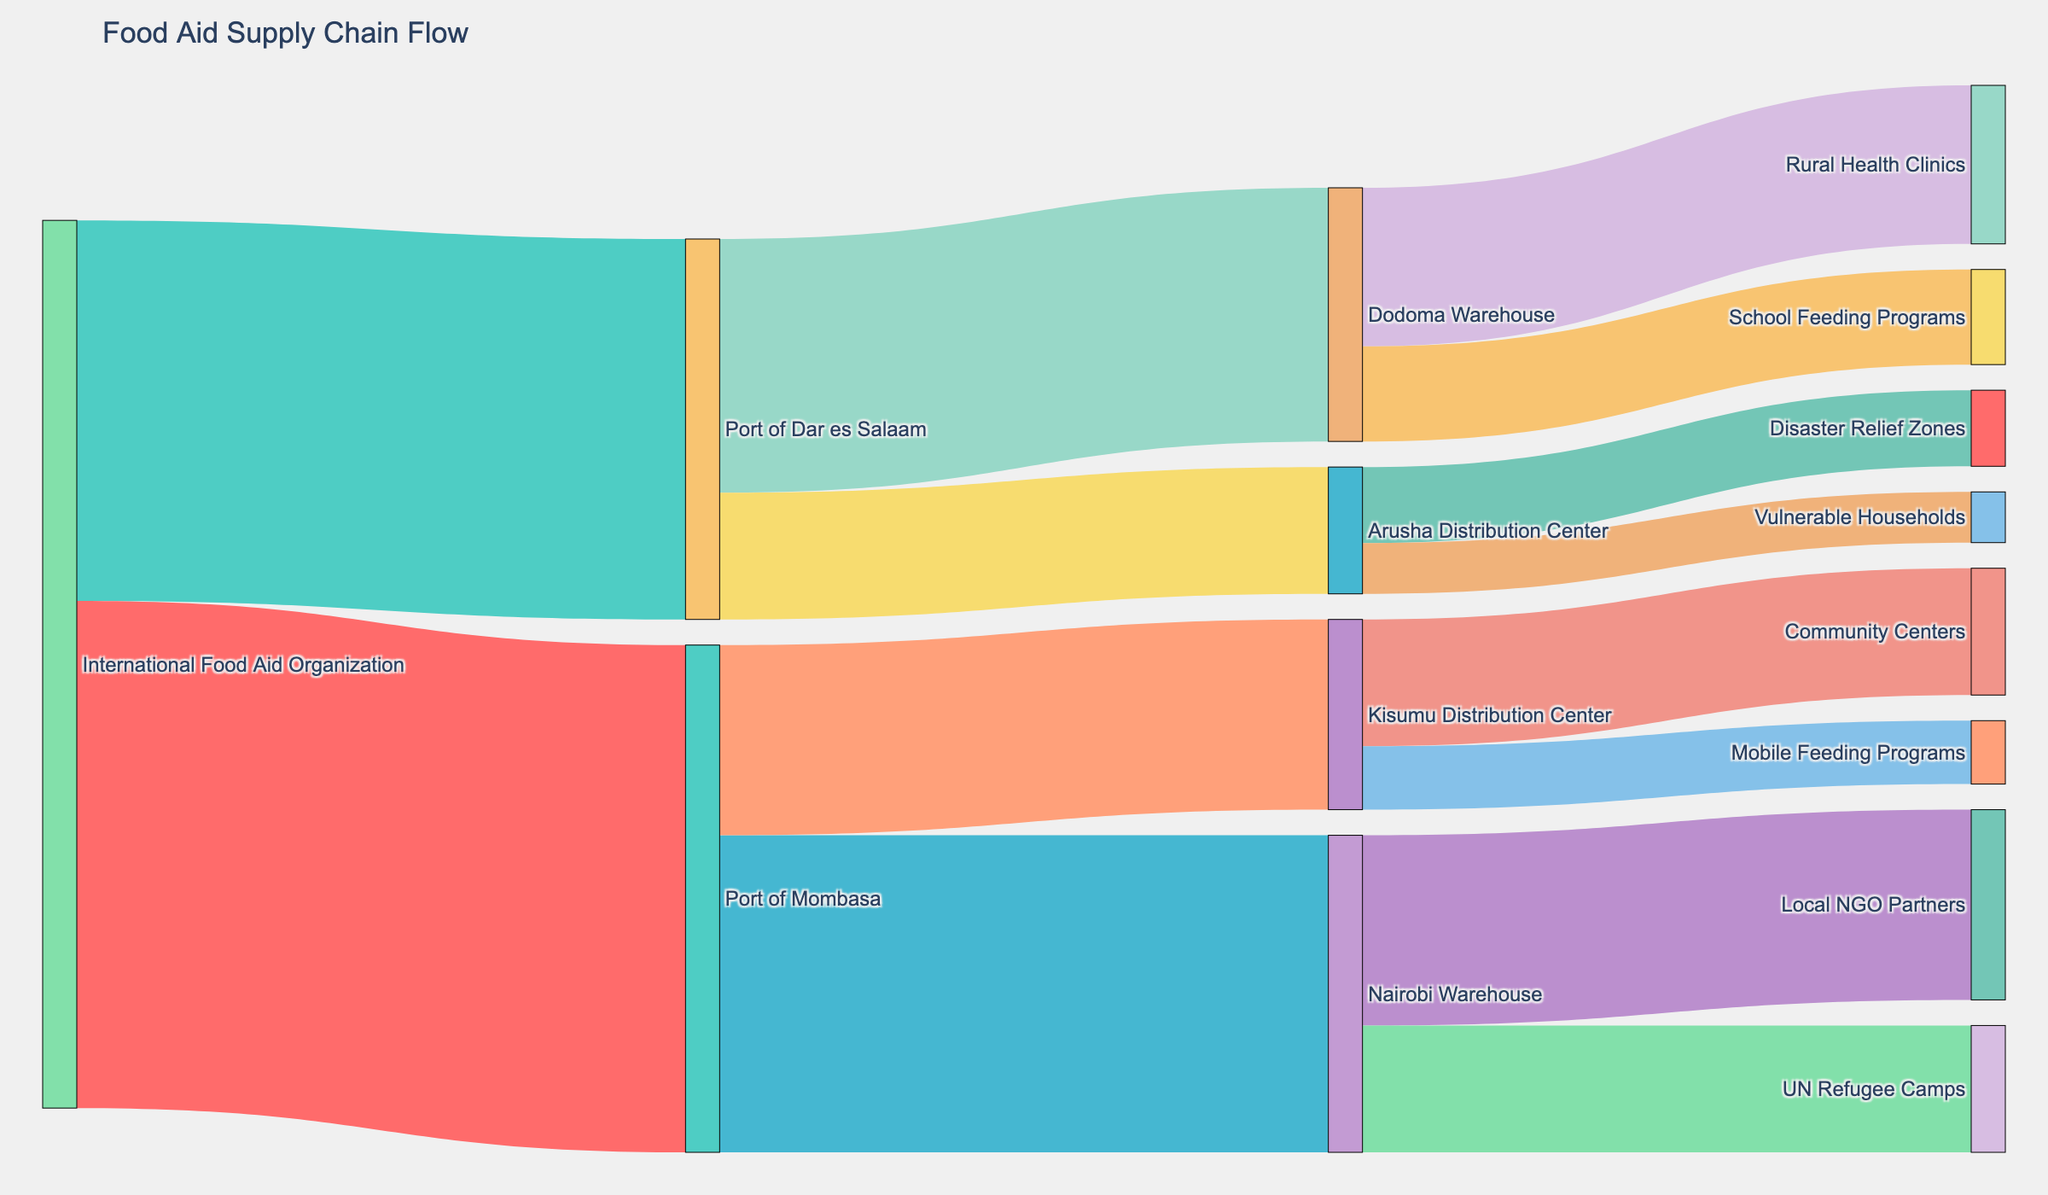Which source point supplies the largest amount of food aid? By looking at the Sankey diagram, the largest flow input is from the International Food Aid Organization to the Port of Mombasa which is 8000 units.
Answer: Port of Mombasa What is the total amount of food aid passing through the Port of Mombasa? To find the total, sum the values associated with the Port of Mombasa: from the International Food Aid Organization to Port of Mombasa (8000), from Port of Mombasa to Nairobi Warehouse (5000), and from Port of Mombasa to Kisumu Distribution Center (3000). The total is 8000.
Answer: 8000 Which distribution center receives more food aid from the Port of Mombasa: Kisumu or Nairobi? Compare the values flowing into both centers: Nairobi Warehouse receives 5000 units, while Kisumu Distribution Center receives 3000 units from the Port of Mombasa.
Answer: Nairobi Warehouse What is the combined value of food aid delivered to Arusha Distribution Center? To calculate the combined value for Arusha Distribution Center, sum its incoming flows: 1200 units for Disaster Relief Zones and 800 units for Vulnerable Households, which totals 2000 units.
Answer: 2000 Which target receives food aid from the Dodoma Warehouse through indirect sources? According to the Sankey diagram, the Dodoma Warehouse sends food aid to Rural Health Clinics (2500) and School Feeding Programs (1500), and these flows originate from the Port of Dar es Salaam.
Answer: Rural Health Clinics and School Feeding Programs What is the difference between the food aid directed to UN Refugee Camps and Community Centers? The flow going to UN Refugee Camps is 2000 units and the flow to Community Centers is 2000 units. The difference between them is 2000 minus 2000 which is 0.
Answer: 0 From which initial source does the Vulnerable Households receive their food aid? By following the diagram, the flow to Vulnerable Households (800 units) comes from Arusha Distribution Center, and Arusha Distribution Center initially receives food aid from the Port of Dar es Salaam.
Answer: Port of Dar es Salaam How much food aid is distributed in total by all the warehouses and distribution centers combined? Add all the values flowing out from every warehouse and distribution center: Nairobi (3000+2000), Kisumu (2000+1000), Dodoma (2500+1500), and Arusha (1200+800). The total sum is 3000 + 2000 + 2000 + 1000 + 2500 + 1500 + 1200 + 800 = 14000 units.
Answer: 14000 